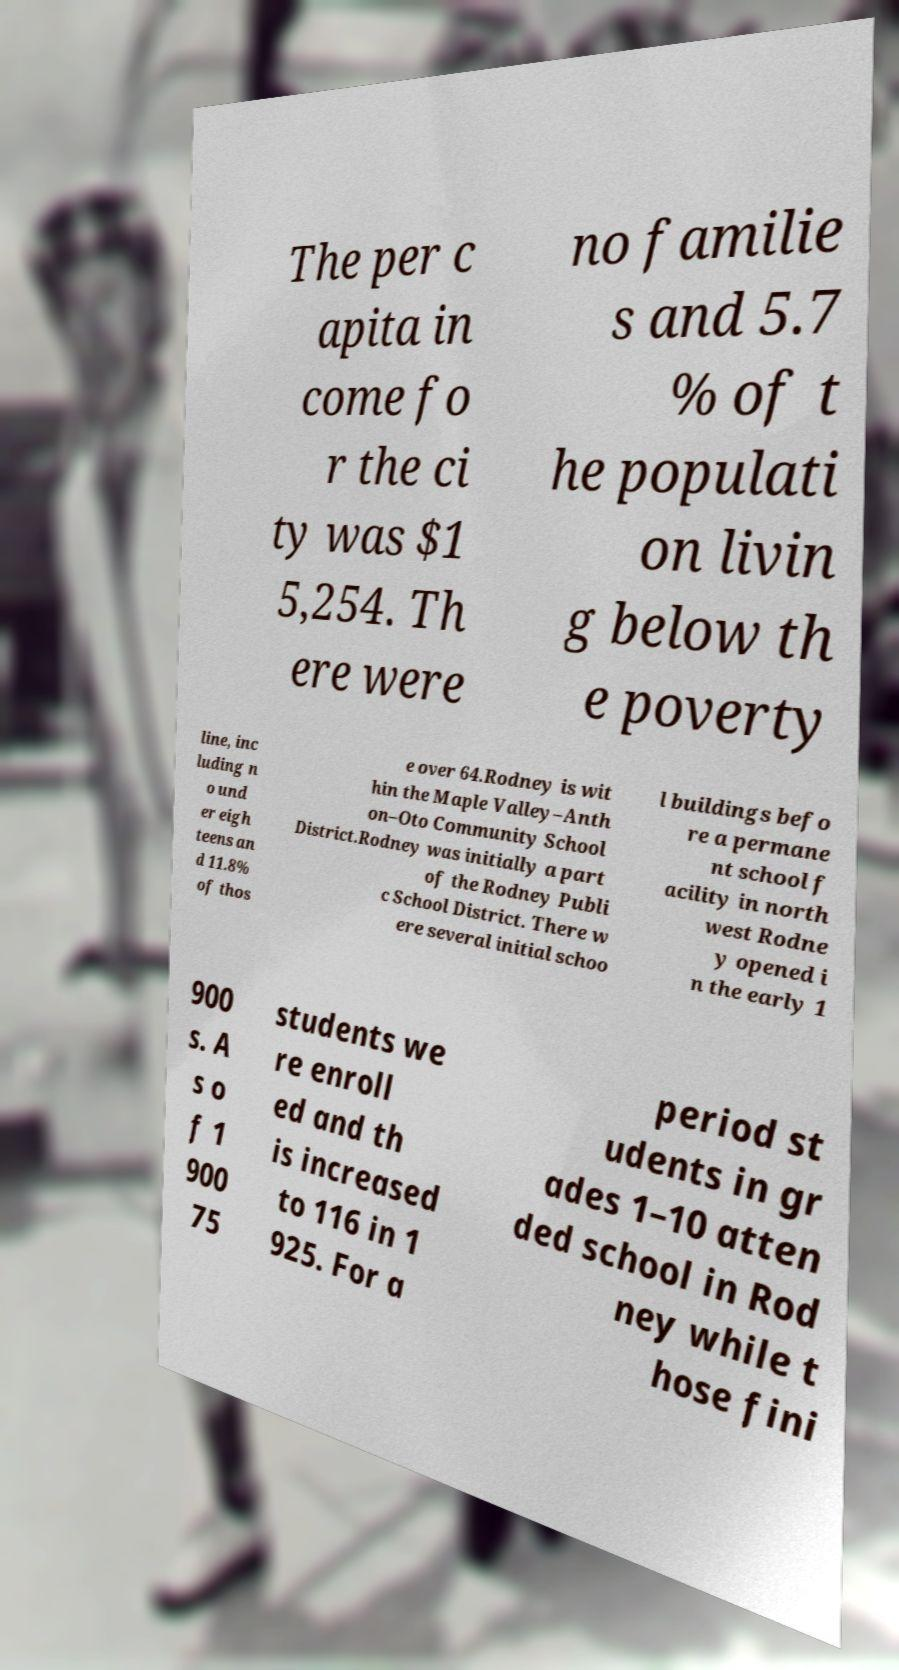Can you read and provide the text displayed in the image?This photo seems to have some interesting text. Can you extract and type it out for me? The per c apita in come fo r the ci ty was $1 5,254. Th ere were no familie s and 5.7 % of t he populati on livin g below th e poverty line, inc luding n o und er eigh teens an d 11.8% of thos e over 64.Rodney is wit hin the Maple Valley–Anth on–Oto Community School District.Rodney was initially a part of the Rodney Publi c School District. There w ere several initial schoo l buildings befo re a permane nt school f acility in north west Rodne y opened i n the early 1 900 s. A s o f 1 900 75 students we re enroll ed and th is increased to 116 in 1 925. For a period st udents in gr ades 1–10 atten ded school in Rod ney while t hose fini 